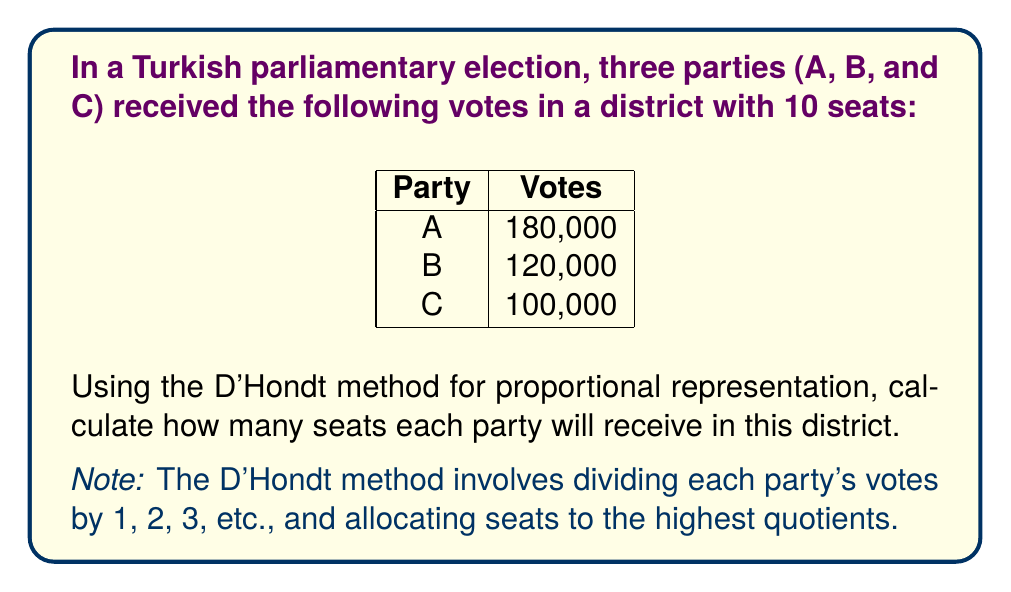Can you solve this math problem? Let's follow the D'Hondt method step-by-step:

1) First, create a table of quotients for each party:

   $$\begin{array}{c|ccc}
   \text{Divisor} & \text{Party A} & \text{Party B} & \text{Party C} \\
   \hline
   1 & 180,000 & 120,000 & 100,000 \\
   2 & 90,000 & 60,000 & 50,000 \\
   3 & 60,000 & 40,000 & 33,333 \\
   4 & 45,000 & 30,000 & 25,000 \\
   5 & 36,000 & 24,000 & 20,000 \\
   \end{array}$$

2) Now, identify the 10 highest quotients (in bold):

   $$\begin{array}{c|ccc}
   \text{Divisor} & \text{Party A} & \text{Party B} & \text{Party C} \\
   \hline
   1 & \mathbf{180,000} & \mathbf{120,000} & \mathbf{100,000} \\
   2 & \mathbf{90,000} & \mathbf{60,000} & \mathbf{50,000} \\
   3 & \mathbf{60,000} & \mathbf{40,000} & 33,333 \\
   4 & \mathbf{45,000} & 30,000 & 25,000 \\
   5 & \mathbf{36,000} & 24,000 & 20,000 \\
   \end{array}$$

3) Count the number of bold entries for each party:

   Party A: 5 seats
   Party B: 3 seats
   Party C: 2 seats

Therefore, the distribution of seats is:
Party A: 5 seats
Party B: 3 seats
Party C: 2 seats
Answer: Party A: 5 seats, Party B: 3 seats, Party C: 2 seats 